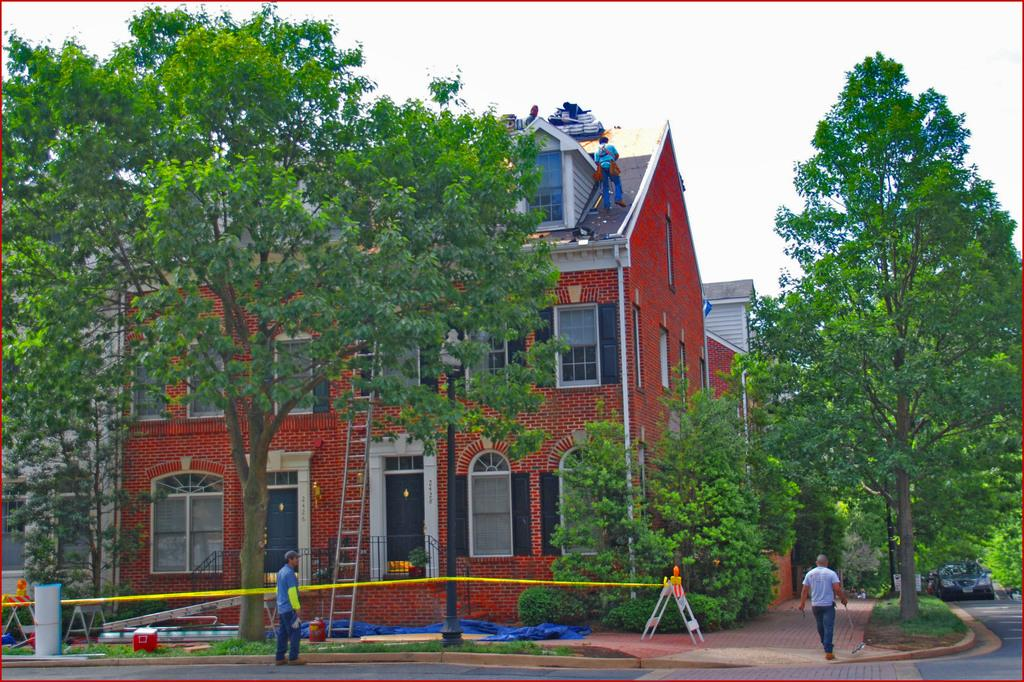What is the main subject of the image? The main subject of the image is a car on the road. Can you describe the people in the image? There are people in the image, but their specific actions or appearances are not mentioned in the facts. What type of vegetation is present in the image? There is grass and trees in the image. What additional objects can be seen in the image? There is a ladder, a box, and other unspecified objects in the image. What type of structures are visible in the image? There are buildings with windows in the image. What can be seen in the background of the image? The sky is visible in the background of the image. How many balls are rolling on the ground in the image? There are no balls present in the image. What type of pan is being used to cook food in the image? There is no pan or cooking activity depicted in the image. 